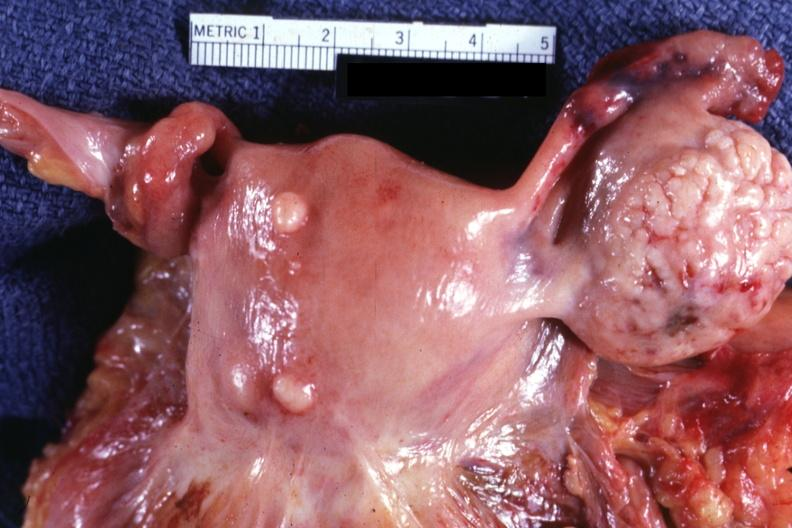s adenoma in photo?
Answer the question using a single word or phrase. No 